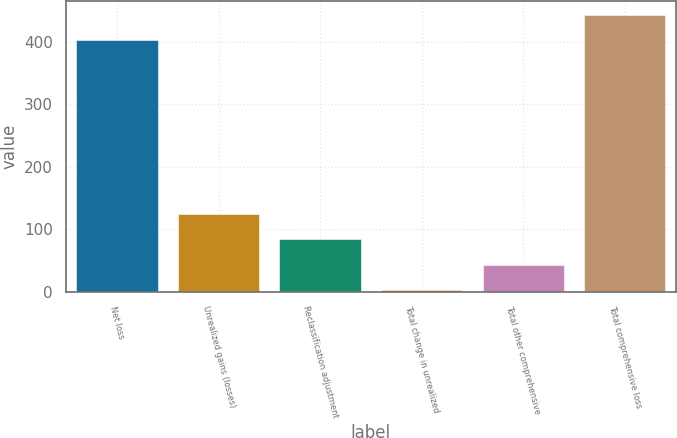Convert chart to OTSL. <chart><loc_0><loc_0><loc_500><loc_500><bar_chart><fcel>Net loss<fcel>Unrealized gains (losses)<fcel>Reclassification adjustment<fcel>Total change in unrealized<fcel>Total other comprehensive<fcel>Total comprehensive loss<nl><fcel>403<fcel>123.9<fcel>83.6<fcel>3<fcel>43.3<fcel>443.3<nl></chart> 